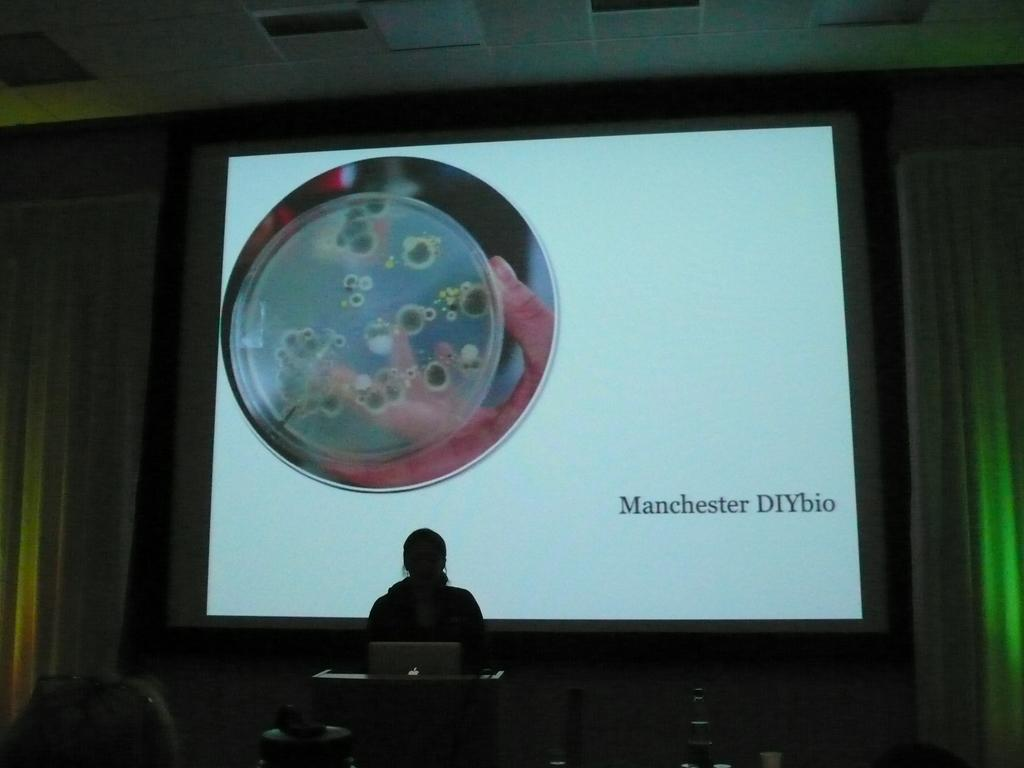<image>
Relay a brief, clear account of the picture shown. A woman is giving a speech with a slide behind her that says Machester DIYbio. 